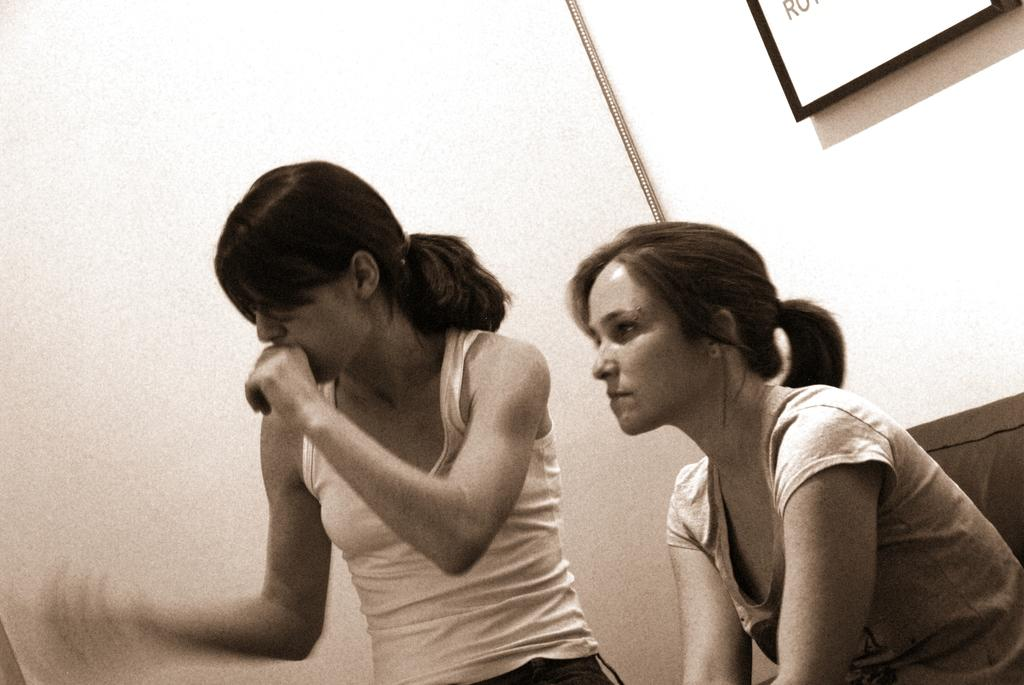How many people are present in the image? There are two ladies in the image. What can be seen in the background of the image? There is a board with text in the background of the image. What is the reaction of the ladies to the boundary in the image? There is no boundary present in the image, and therefore no reaction can be observed. 